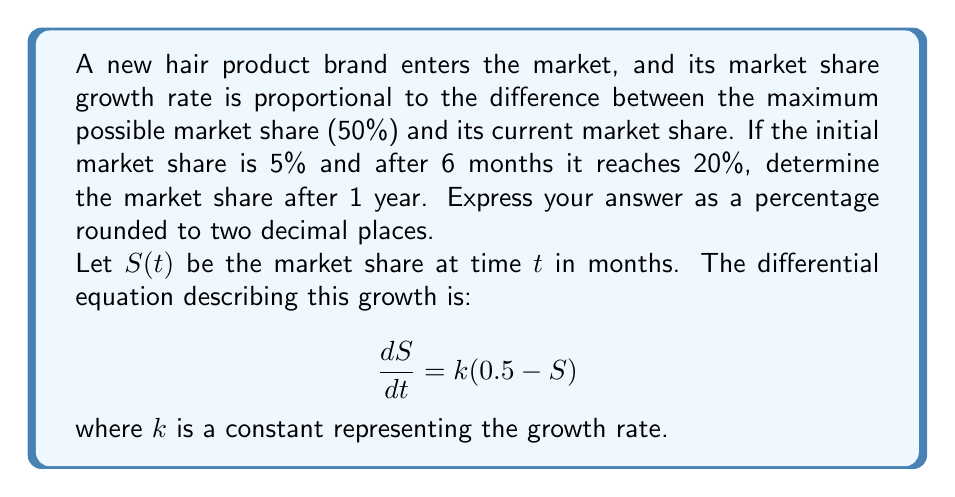What is the answer to this math problem? To solve this problem, we'll follow these steps:

1) First, we need to solve the differential equation:
   $$\frac{dS}{dt} = k(0.5 - S)$$

   This is a separable equation. Rearranging and integrating both sides:
   $$\int \frac{dS}{0.5 - S} = \int k dt$$
   $$-\ln|0.5 - S| = kt + C$$

   Solving for $S$:
   $$S = 0.5 - e^{-(kt + C)} = 0.5 - Ae^{-kt}$$
   where $A = e^{-C}$

2) Now we use the initial condition: $S(0) = 0.05$
   $$0.05 = 0.5 - A$$
   $$A = 0.45$$

   So our solution is:
   $$S = 0.5 - 0.45e^{-kt}$$

3) We can find $k$ using the condition that $S(6) = 0.20$:
   $$0.20 = 0.5 - 0.45e^{-6k}$$
   $$0.30 = 0.45e^{-6k}$$
   $$\ln(0.6667) = -6k$$
   $$k = 0.0680$$

4) Now we have the complete solution:
   $$S = 0.5 - 0.45e^{-0.0680t}$$

5) To find the market share after 1 year (12 months), we calculate $S(12)$:
   $$S(12) = 0.5 - 0.45e^{-0.0680(12)}$$
   $$S(12) = 0.5 - 0.45e^{-0.8160}$$
   $$S(12) = 0.5 - 0.45(0.4422)$$
   $$S(12) = 0.5 - 0.1990$$
   $$S(12) = 0.3010$$

6) Converting to a percentage and rounding to two decimal places:
   $$S(12) = 30.10\%$$
Answer: 30.10% 